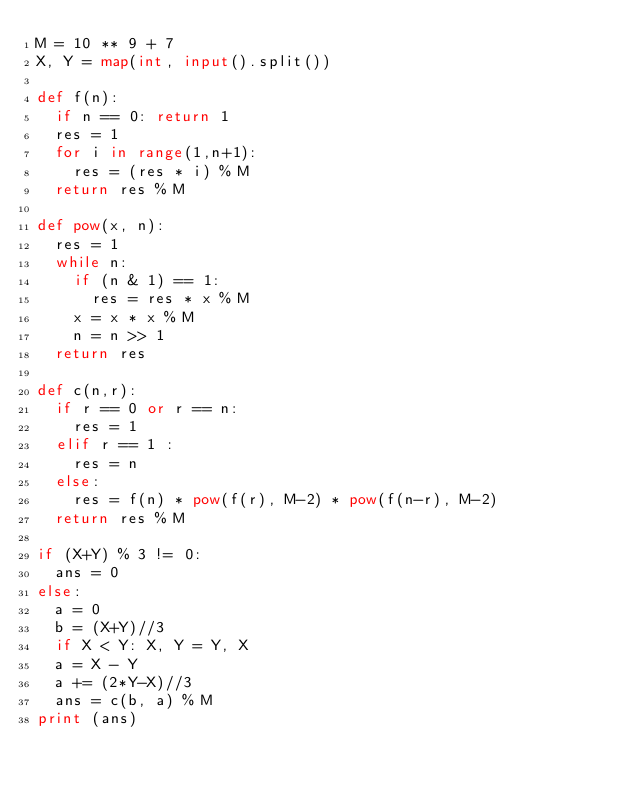Convert code to text. <code><loc_0><loc_0><loc_500><loc_500><_Python_>M = 10 ** 9 + 7
X, Y = map(int, input().split())

def f(n):
  if n == 0: return 1
  res = 1
  for i in range(1,n+1):
    res = (res * i) % M
  return res % M

def pow(x, n):
  res = 1
  while n:
    if (n & 1) == 1:
      res = res * x % M
    x = x * x % M
    n = n >> 1
  return res

def c(n,r):
  if r == 0 or r == n:
    res = 1
  elif r == 1 :
    res = n
  else:
    res = f(n) * pow(f(r), M-2) * pow(f(n-r), M-2)
  return res % M

if (X+Y) % 3 != 0:
  ans = 0
else:
  a = 0
  b = (X+Y)//3
  if X < Y: X, Y = Y, X
  a = X - Y
  a += (2*Y-X)//3
  ans = c(b, a) % M
print (ans)</code> 